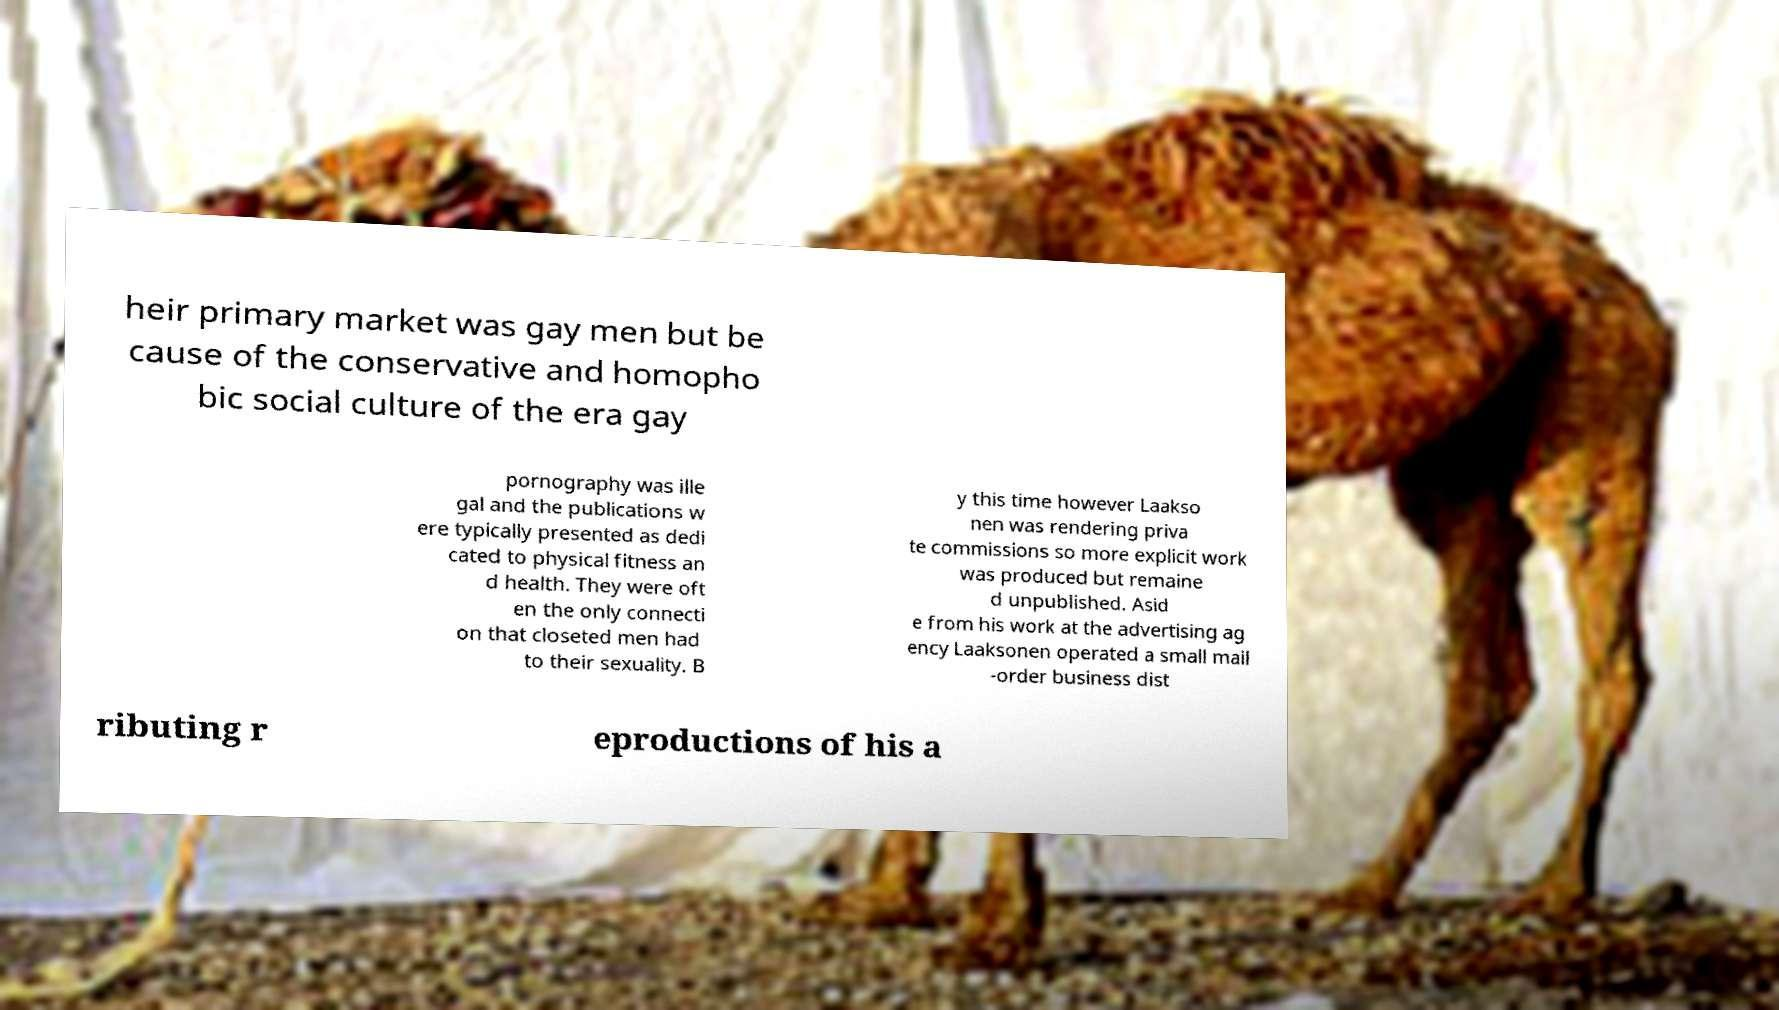There's text embedded in this image that I need extracted. Can you transcribe it verbatim? heir primary market was gay men but be cause of the conservative and homopho bic social culture of the era gay pornography was ille gal and the publications w ere typically presented as dedi cated to physical fitness an d health. They were oft en the only connecti on that closeted men had to their sexuality. B y this time however Laakso nen was rendering priva te commissions so more explicit work was produced but remaine d unpublished. Asid e from his work at the advertising ag ency Laaksonen operated a small mail -order business dist ributing r eproductions of his a 